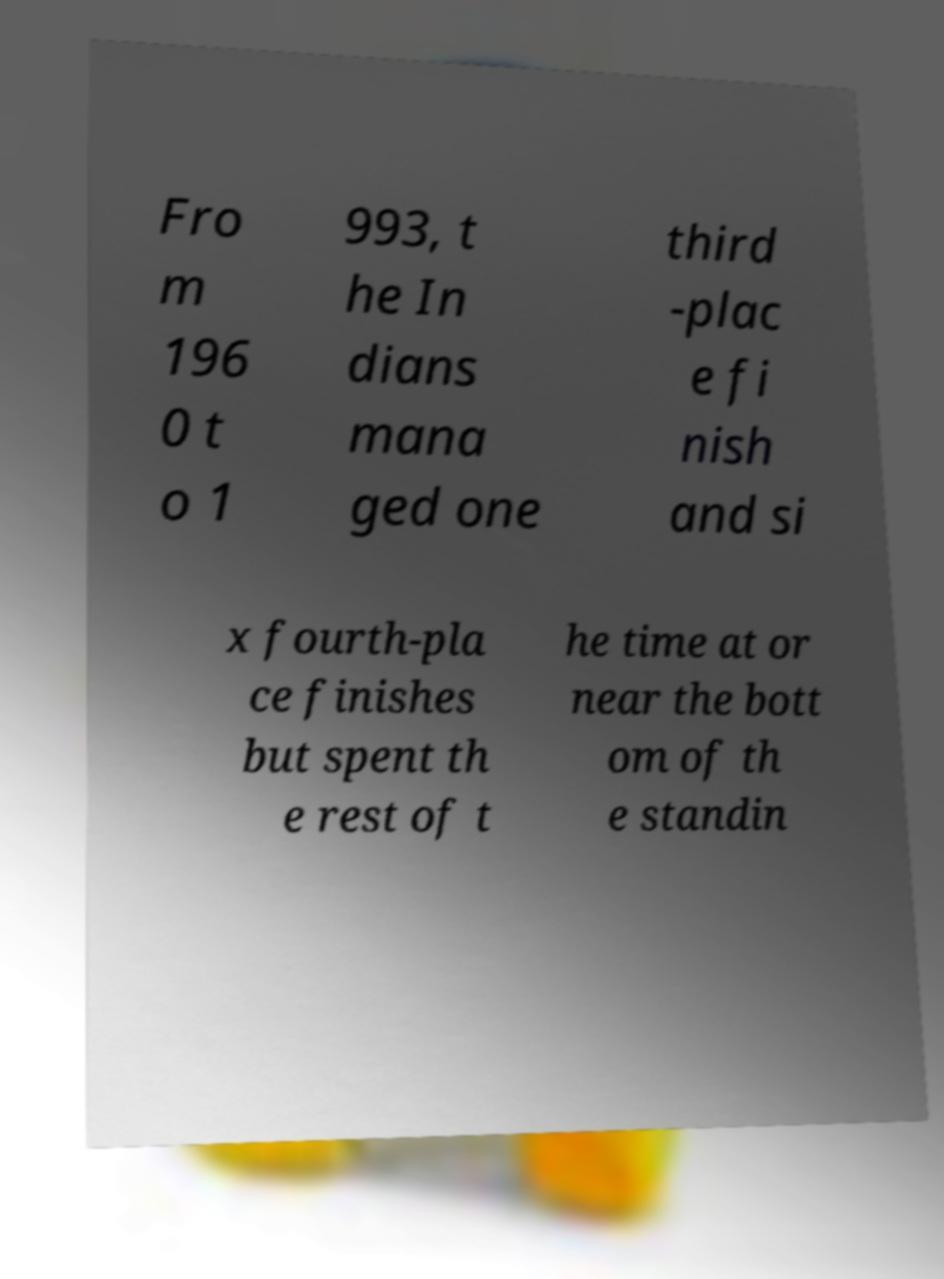There's text embedded in this image that I need extracted. Can you transcribe it verbatim? Fro m 196 0 t o 1 993, t he In dians mana ged one third -plac e fi nish and si x fourth-pla ce finishes but spent th e rest of t he time at or near the bott om of th e standin 